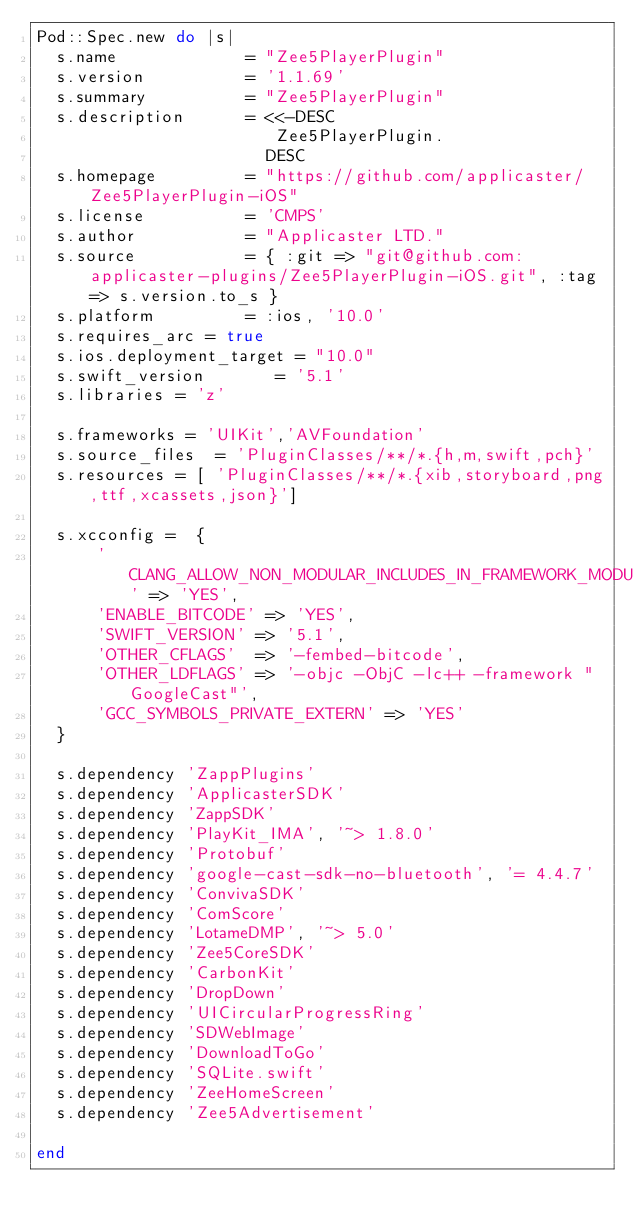<code> <loc_0><loc_0><loc_500><loc_500><_Ruby_>Pod::Spec.new do |s|
  s.name             = "Zee5PlayerPlugin"
  s.version          = '1.1.69'
  s.summary          = "Zee5PlayerPlugin"
  s.description      = <<-DESC
                        Zee5PlayerPlugin.
                       DESC
  s.homepage         = "https://github.com/applicaster/Zee5PlayerPlugin-iOS"
  s.license          = 'CMPS'
  s.author           = "Applicaster LTD."
  s.source           = { :git => "git@github.com:applicaster-plugins/Zee5PlayerPlugin-iOS.git", :tag => s.version.to_s }
  s.platform         = :ios, '10.0'
  s.requires_arc = true
  s.ios.deployment_target = "10.0"
  s.swift_version       = '5.1'
  s.libraries = 'z'

  s.frameworks = 'UIKit','AVFoundation'
  s.source_files  = 'PluginClasses/**/*.{h,m,swift,pch}'
  s.resources = [ 'PluginClasses/**/*.{xib,storyboard,png,ttf,xcassets,json}']

  s.xcconfig =  {
      'CLANG_ALLOW_NON_MODULAR_INCLUDES_IN_FRAMEWORK_MODULES' => 'YES',
      'ENABLE_BITCODE' => 'YES',
      'SWIFT_VERSION' => '5.1',
      'OTHER_CFLAGS'  => '-fembed-bitcode',
      'OTHER_LDFLAGS' => '-objc -ObjC -lc++ -framework "GoogleCast"',
      'GCC_SYMBOLS_PRIVATE_EXTERN' => 'YES'
  }

  s.dependency 'ZappPlugins'
  s.dependency 'ApplicasterSDK'
  s.dependency 'ZappSDK'
  s.dependency 'PlayKit_IMA', '~> 1.8.0'
  s.dependency 'Protobuf'
  s.dependency 'google-cast-sdk-no-bluetooth', '= 4.4.7'
  s.dependency 'ConvivaSDK'
  s.dependency 'ComScore'
  s.dependency 'LotameDMP', '~> 5.0'
  s.dependency 'Zee5CoreSDK'
  s.dependency 'CarbonKit'
  s.dependency 'DropDown'
  s.dependency 'UICircularProgressRing'
  s.dependency 'SDWebImage'
  s.dependency 'DownloadToGo'
  s.dependency 'SQLite.swift'
  s.dependency 'ZeeHomeScreen'
  s.dependency 'Zee5Advertisement'

end
</code> 